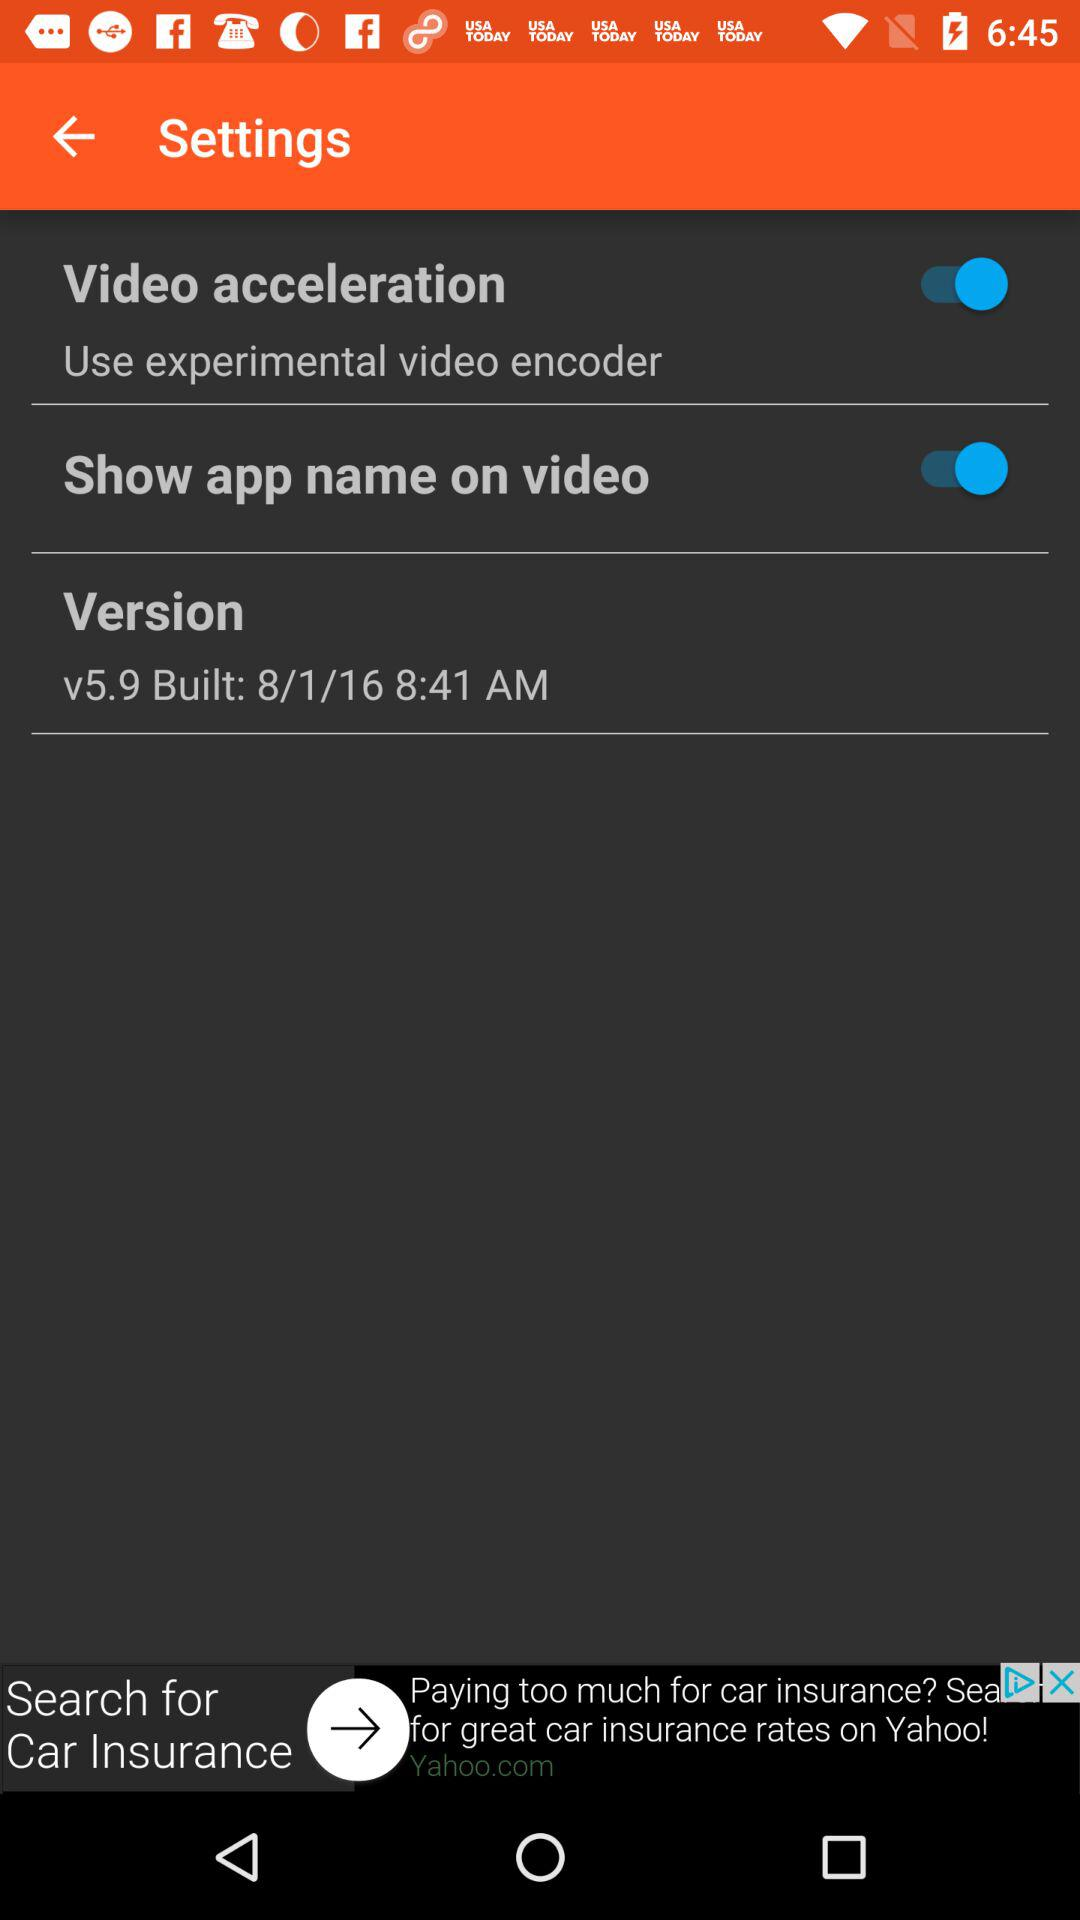How many items have a switch?
Answer the question using a single word or phrase. 2 